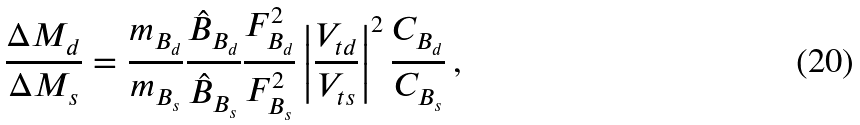<formula> <loc_0><loc_0><loc_500><loc_500>\frac { \Delta M _ { d } } { \Delta M _ { s } } = \frac { m _ { B _ { d } } } { m _ { B _ { s } } } \frac { \hat { B } _ { B _ { d } } } { \hat { B } _ { B _ { s } } } \frac { F _ { B _ { d } } ^ { 2 } } { F _ { B _ { s } } ^ { 2 } } \left | \frac { V _ { t d } } { V _ { t s } } \right | ^ { 2 } \frac { C _ { B _ { d } } } { C _ { B _ { s } } } \, ,</formula> 